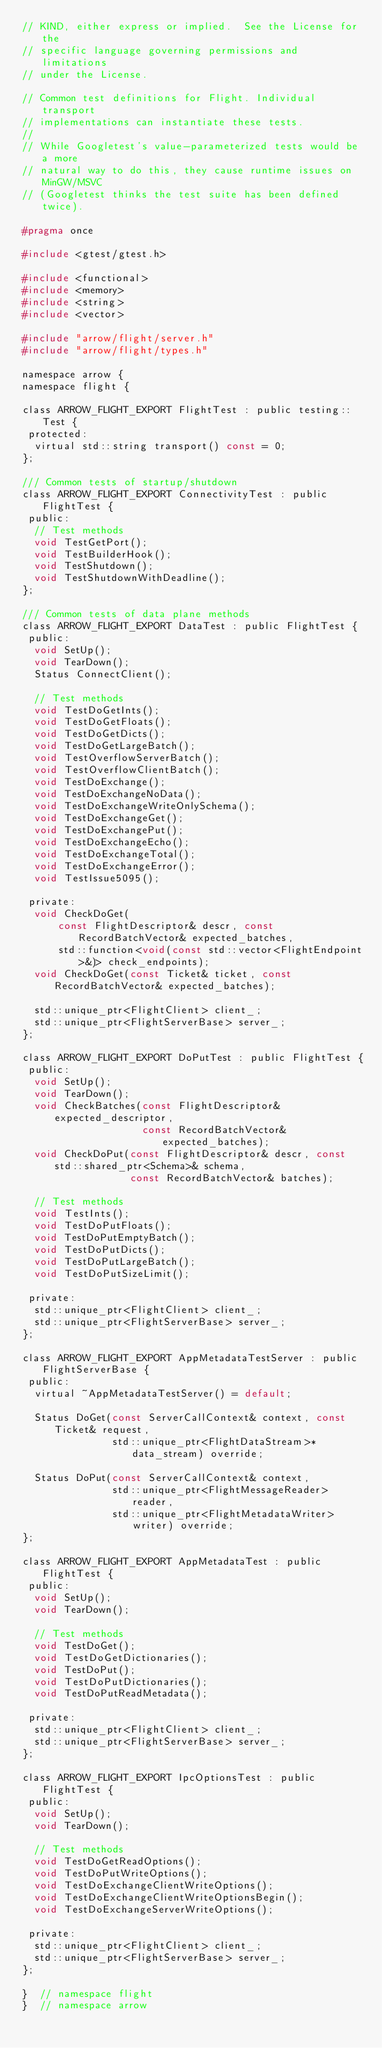Convert code to text. <code><loc_0><loc_0><loc_500><loc_500><_C_>// KIND, either express or implied.  See the License for the
// specific language governing permissions and limitations
// under the License.

// Common test definitions for Flight. Individual transport
// implementations can instantiate these tests.
//
// While Googletest's value-parameterized tests would be a more
// natural way to do this, they cause runtime issues on MinGW/MSVC
// (Googletest thinks the test suite has been defined twice).

#pragma once

#include <gtest/gtest.h>

#include <functional>
#include <memory>
#include <string>
#include <vector>

#include "arrow/flight/server.h"
#include "arrow/flight/types.h"

namespace arrow {
namespace flight {

class ARROW_FLIGHT_EXPORT FlightTest : public testing::Test {
 protected:
  virtual std::string transport() const = 0;
};

/// Common tests of startup/shutdown
class ARROW_FLIGHT_EXPORT ConnectivityTest : public FlightTest {
 public:
  // Test methods
  void TestGetPort();
  void TestBuilderHook();
  void TestShutdown();
  void TestShutdownWithDeadline();
};

/// Common tests of data plane methods
class ARROW_FLIGHT_EXPORT DataTest : public FlightTest {
 public:
  void SetUp();
  void TearDown();
  Status ConnectClient();

  // Test methods
  void TestDoGetInts();
  void TestDoGetFloats();
  void TestDoGetDicts();
  void TestDoGetLargeBatch();
  void TestOverflowServerBatch();
  void TestOverflowClientBatch();
  void TestDoExchange();
  void TestDoExchangeNoData();
  void TestDoExchangeWriteOnlySchema();
  void TestDoExchangeGet();
  void TestDoExchangePut();
  void TestDoExchangeEcho();
  void TestDoExchangeTotal();
  void TestDoExchangeError();
  void TestIssue5095();

 private:
  void CheckDoGet(
      const FlightDescriptor& descr, const RecordBatchVector& expected_batches,
      std::function<void(const std::vector<FlightEndpoint>&)> check_endpoints);
  void CheckDoGet(const Ticket& ticket, const RecordBatchVector& expected_batches);

  std::unique_ptr<FlightClient> client_;
  std::unique_ptr<FlightServerBase> server_;
};

class ARROW_FLIGHT_EXPORT DoPutTest : public FlightTest {
 public:
  void SetUp();
  void TearDown();
  void CheckBatches(const FlightDescriptor& expected_descriptor,
                    const RecordBatchVector& expected_batches);
  void CheckDoPut(const FlightDescriptor& descr, const std::shared_ptr<Schema>& schema,
                  const RecordBatchVector& batches);

  // Test methods
  void TestInts();
  void TestDoPutFloats();
  void TestDoPutEmptyBatch();
  void TestDoPutDicts();
  void TestDoPutLargeBatch();
  void TestDoPutSizeLimit();

 private:
  std::unique_ptr<FlightClient> client_;
  std::unique_ptr<FlightServerBase> server_;
};

class ARROW_FLIGHT_EXPORT AppMetadataTestServer : public FlightServerBase {
 public:
  virtual ~AppMetadataTestServer() = default;

  Status DoGet(const ServerCallContext& context, const Ticket& request,
               std::unique_ptr<FlightDataStream>* data_stream) override;

  Status DoPut(const ServerCallContext& context,
               std::unique_ptr<FlightMessageReader> reader,
               std::unique_ptr<FlightMetadataWriter> writer) override;
};

class ARROW_FLIGHT_EXPORT AppMetadataTest : public FlightTest {
 public:
  void SetUp();
  void TearDown();

  // Test methods
  void TestDoGet();
  void TestDoGetDictionaries();
  void TestDoPut();
  void TestDoPutDictionaries();
  void TestDoPutReadMetadata();

 private:
  std::unique_ptr<FlightClient> client_;
  std::unique_ptr<FlightServerBase> server_;
};

class ARROW_FLIGHT_EXPORT IpcOptionsTest : public FlightTest {
 public:
  void SetUp();
  void TearDown();

  // Test methods
  void TestDoGetReadOptions();
  void TestDoPutWriteOptions();
  void TestDoExchangeClientWriteOptions();
  void TestDoExchangeClientWriteOptionsBegin();
  void TestDoExchangeServerWriteOptions();

 private:
  std::unique_ptr<FlightClient> client_;
  std::unique_ptr<FlightServerBase> server_;
};

}  // namespace flight
}  // namespace arrow
</code> 